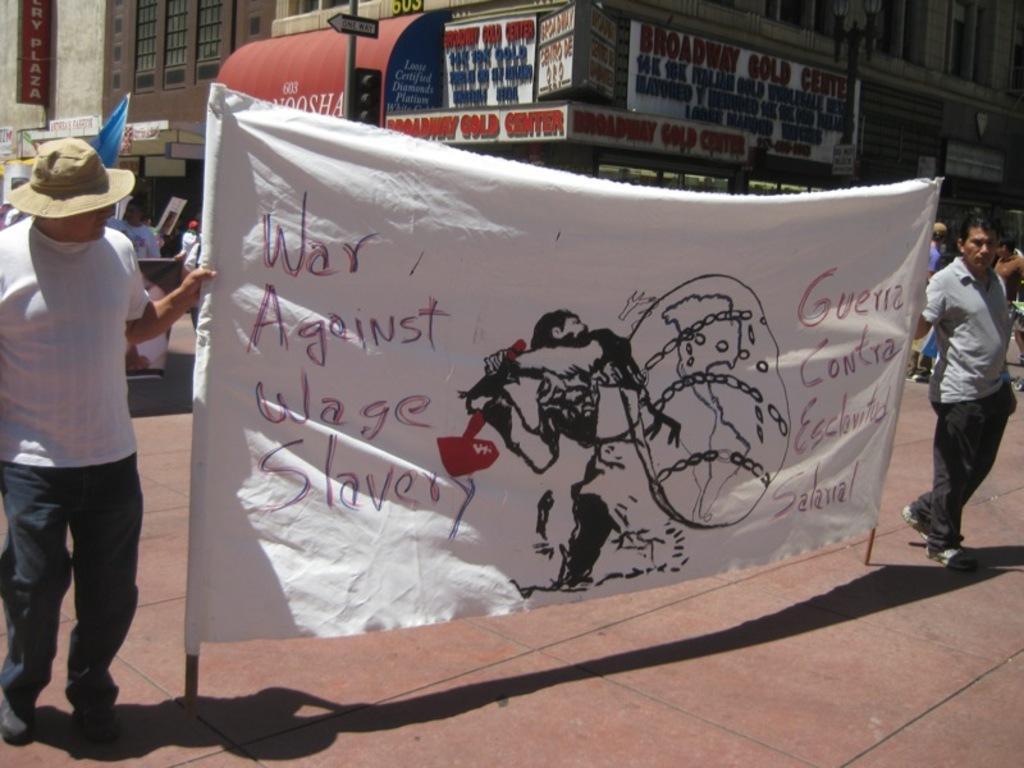Could you give a brief overview of what you see in this image? In this image we can see two persons holding a banner with some text an a picture and behind we can see some people. There is a building in the background and we can see some boards with the text and there is a pole with traffic lights and a board. 